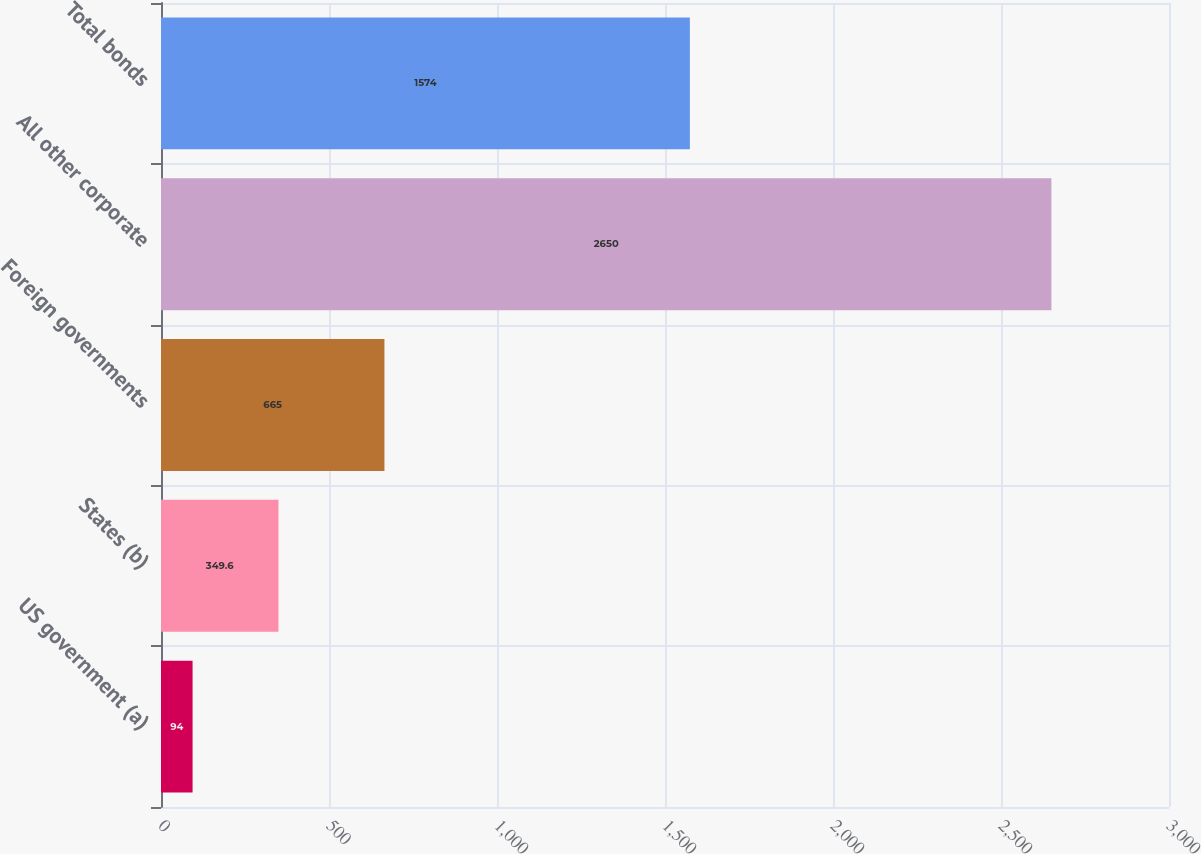<chart> <loc_0><loc_0><loc_500><loc_500><bar_chart><fcel>US government (a)<fcel>States (b)<fcel>Foreign governments<fcel>All other corporate<fcel>Total bonds<nl><fcel>94<fcel>349.6<fcel>665<fcel>2650<fcel>1574<nl></chart> 